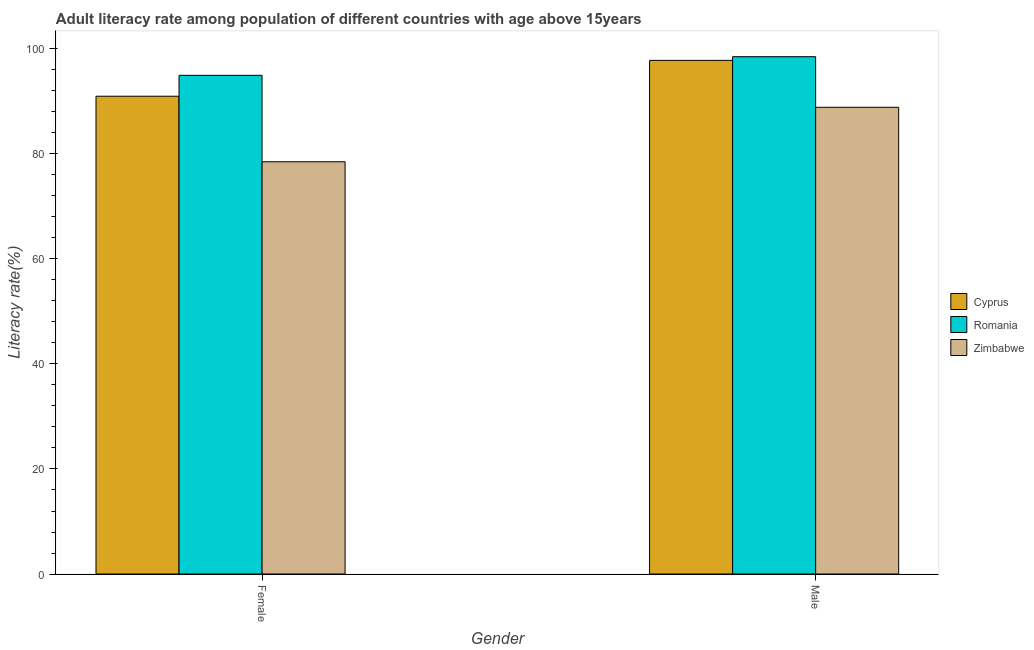How many different coloured bars are there?
Provide a short and direct response. 3. Are the number of bars per tick equal to the number of legend labels?
Provide a short and direct response. Yes. How many bars are there on the 1st tick from the left?
Offer a terse response. 3. What is the female adult literacy rate in Cyprus?
Your answer should be very brief. 91. Across all countries, what is the maximum male adult literacy rate?
Your answer should be compact. 98.53. Across all countries, what is the minimum female adult literacy rate?
Offer a very short reply. 78.52. In which country was the female adult literacy rate maximum?
Your answer should be very brief. Romania. In which country was the male adult literacy rate minimum?
Provide a succinct answer. Zimbabwe. What is the total male adult literacy rate in the graph?
Keep it short and to the point. 285.26. What is the difference between the male adult literacy rate in Cyprus and that in Zimbabwe?
Offer a very short reply. 8.94. What is the difference between the male adult literacy rate in Romania and the female adult literacy rate in Zimbabwe?
Ensure brevity in your answer.  20.02. What is the average female adult literacy rate per country?
Keep it short and to the point. 88.17. What is the difference between the male adult literacy rate and female adult literacy rate in Romania?
Your answer should be very brief. 3.55. In how many countries, is the male adult literacy rate greater than 16 %?
Provide a succinct answer. 3. What is the ratio of the female adult literacy rate in Zimbabwe to that in Cyprus?
Ensure brevity in your answer.  0.86. In how many countries, is the female adult literacy rate greater than the average female adult literacy rate taken over all countries?
Offer a terse response. 2. What does the 2nd bar from the left in Female represents?
Give a very brief answer. Romania. What does the 1st bar from the right in Female represents?
Your answer should be compact. Zimbabwe. Are all the bars in the graph horizontal?
Offer a terse response. No. Are the values on the major ticks of Y-axis written in scientific E-notation?
Keep it short and to the point. No. Where does the legend appear in the graph?
Offer a terse response. Center right. How many legend labels are there?
Provide a short and direct response. 3. How are the legend labels stacked?
Your answer should be compact. Vertical. What is the title of the graph?
Offer a very short reply. Adult literacy rate among population of different countries with age above 15years. Does "OECD members" appear as one of the legend labels in the graph?
Keep it short and to the point. No. What is the label or title of the X-axis?
Give a very brief answer. Gender. What is the label or title of the Y-axis?
Provide a short and direct response. Literacy rate(%). What is the Literacy rate(%) of Cyprus in Female?
Your response must be concise. 91. What is the Literacy rate(%) of Romania in Female?
Provide a short and direct response. 94.98. What is the Literacy rate(%) in Zimbabwe in Female?
Your response must be concise. 78.52. What is the Literacy rate(%) in Cyprus in Male?
Offer a terse response. 97.83. What is the Literacy rate(%) of Romania in Male?
Offer a terse response. 98.53. What is the Literacy rate(%) of Zimbabwe in Male?
Give a very brief answer. 88.89. Across all Gender, what is the maximum Literacy rate(%) of Cyprus?
Your answer should be very brief. 97.83. Across all Gender, what is the maximum Literacy rate(%) of Romania?
Give a very brief answer. 98.53. Across all Gender, what is the maximum Literacy rate(%) of Zimbabwe?
Offer a terse response. 88.89. Across all Gender, what is the minimum Literacy rate(%) of Cyprus?
Your answer should be very brief. 91. Across all Gender, what is the minimum Literacy rate(%) of Romania?
Offer a terse response. 94.98. Across all Gender, what is the minimum Literacy rate(%) of Zimbabwe?
Keep it short and to the point. 78.52. What is the total Literacy rate(%) of Cyprus in the graph?
Provide a succinct answer. 188.83. What is the total Literacy rate(%) in Romania in the graph?
Your response must be concise. 193.51. What is the total Literacy rate(%) in Zimbabwe in the graph?
Make the answer very short. 167.41. What is the difference between the Literacy rate(%) in Cyprus in Female and that in Male?
Provide a short and direct response. -6.83. What is the difference between the Literacy rate(%) in Romania in Female and that in Male?
Give a very brief answer. -3.55. What is the difference between the Literacy rate(%) of Zimbabwe in Female and that in Male?
Offer a very short reply. -10.38. What is the difference between the Literacy rate(%) of Cyprus in Female and the Literacy rate(%) of Romania in Male?
Your answer should be very brief. -7.53. What is the difference between the Literacy rate(%) of Cyprus in Female and the Literacy rate(%) of Zimbabwe in Male?
Offer a very short reply. 2.11. What is the difference between the Literacy rate(%) of Romania in Female and the Literacy rate(%) of Zimbabwe in Male?
Ensure brevity in your answer.  6.09. What is the average Literacy rate(%) in Cyprus per Gender?
Your answer should be very brief. 94.42. What is the average Literacy rate(%) in Romania per Gender?
Your answer should be very brief. 96.76. What is the average Literacy rate(%) of Zimbabwe per Gender?
Your response must be concise. 83.71. What is the difference between the Literacy rate(%) of Cyprus and Literacy rate(%) of Romania in Female?
Give a very brief answer. -3.98. What is the difference between the Literacy rate(%) in Cyprus and Literacy rate(%) in Zimbabwe in Female?
Provide a short and direct response. 12.48. What is the difference between the Literacy rate(%) of Romania and Literacy rate(%) of Zimbabwe in Female?
Provide a short and direct response. 16.47. What is the difference between the Literacy rate(%) in Cyprus and Literacy rate(%) in Romania in Male?
Give a very brief answer. -0.7. What is the difference between the Literacy rate(%) in Cyprus and Literacy rate(%) in Zimbabwe in Male?
Provide a short and direct response. 8.94. What is the difference between the Literacy rate(%) in Romania and Literacy rate(%) in Zimbabwe in Male?
Offer a terse response. 9.64. What is the ratio of the Literacy rate(%) in Cyprus in Female to that in Male?
Provide a short and direct response. 0.93. What is the ratio of the Literacy rate(%) in Romania in Female to that in Male?
Your response must be concise. 0.96. What is the ratio of the Literacy rate(%) of Zimbabwe in Female to that in Male?
Ensure brevity in your answer.  0.88. What is the difference between the highest and the second highest Literacy rate(%) in Cyprus?
Make the answer very short. 6.83. What is the difference between the highest and the second highest Literacy rate(%) in Romania?
Your response must be concise. 3.55. What is the difference between the highest and the second highest Literacy rate(%) in Zimbabwe?
Provide a short and direct response. 10.38. What is the difference between the highest and the lowest Literacy rate(%) of Cyprus?
Provide a short and direct response. 6.83. What is the difference between the highest and the lowest Literacy rate(%) in Romania?
Offer a terse response. 3.55. What is the difference between the highest and the lowest Literacy rate(%) of Zimbabwe?
Make the answer very short. 10.38. 